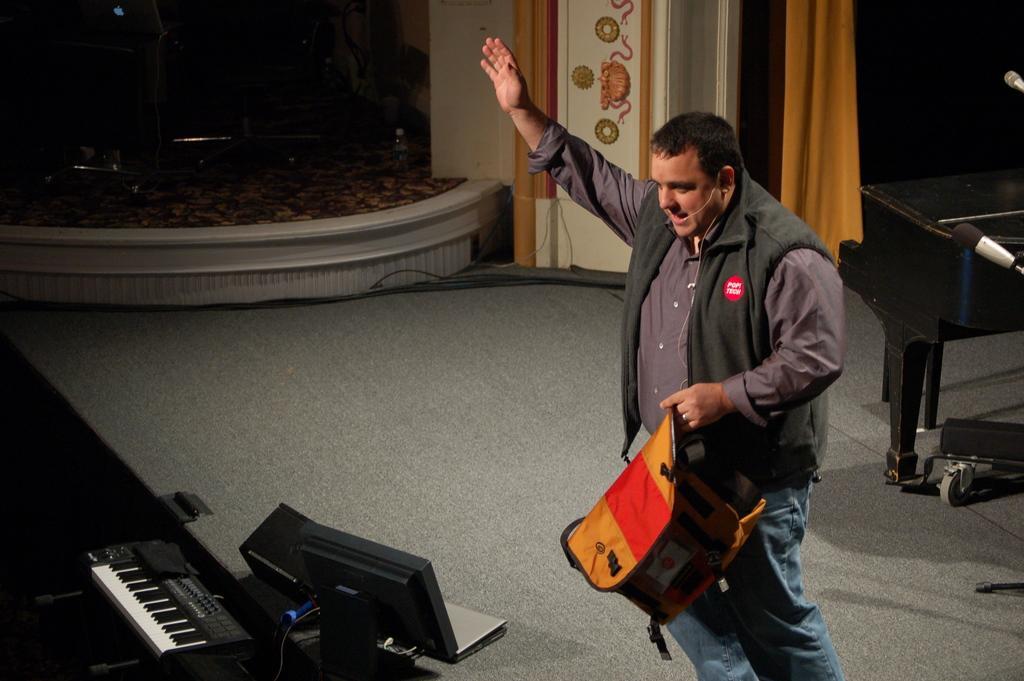Can you describe this image briefly? As we can see in the image, there is a man standing on floor and holding a bag and on the left side there is a musical keyboard. On the right there is mike. Behind the man there is a white color wall and orange color curtain. 